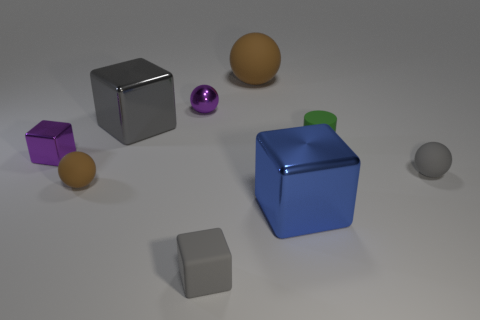Subtract all gray cubes. How many brown balls are left? 2 Subtract all purple cubes. How many cubes are left? 3 Subtract 2 cubes. How many cubes are left? 2 Subtract all purple shiny spheres. How many spheres are left? 3 Add 1 brown matte things. How many objects exist? 10 Subtract all red balls. Subtract all gray cubes. How many balls are left? 4 Subtract all cylinders. How many objects are left? 8 Subtract all small rubber spheres. Subtract all big shiny things. How many objects are left? 5 Add 5 small purple balls. How many small purple balls are left? 6 Add 1 large green shiny objects. How many large green shiny objects exist? 1 